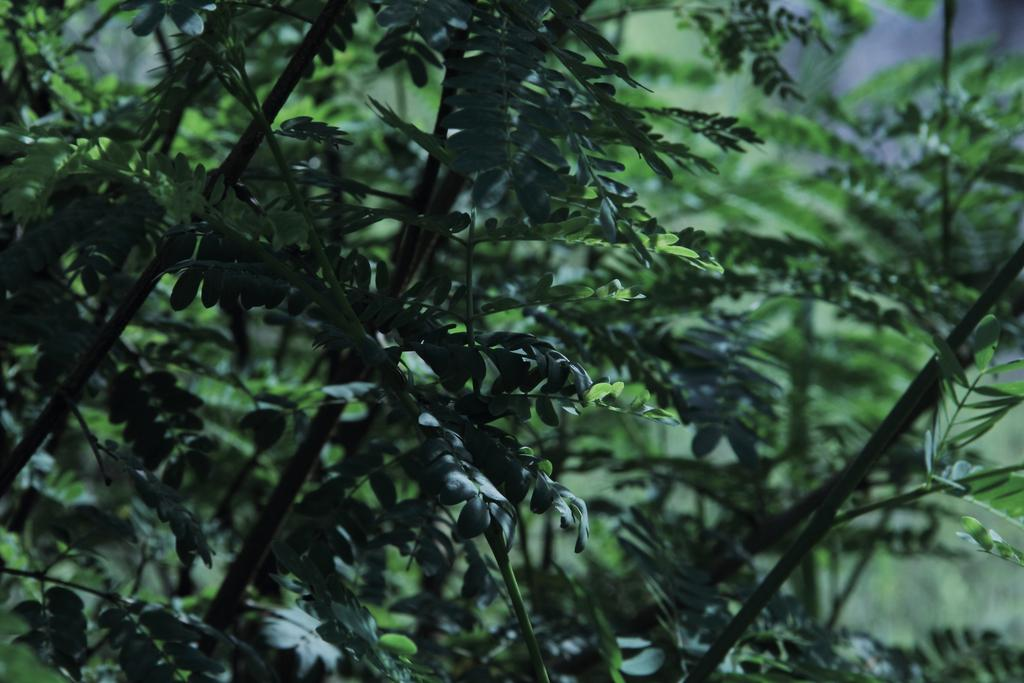What type of vegetation can be seen in the image? There are trees in the image. What color are the trees? The trees are green in color. Can you describe the background of the image? The background of the image is blurry. What type of leather material is used to make the basket in the image? There is no basket or leather material present in the image. On what type of table are the trees placed in the image? The trees are not placed on a table in the image; they are standing on their own. 